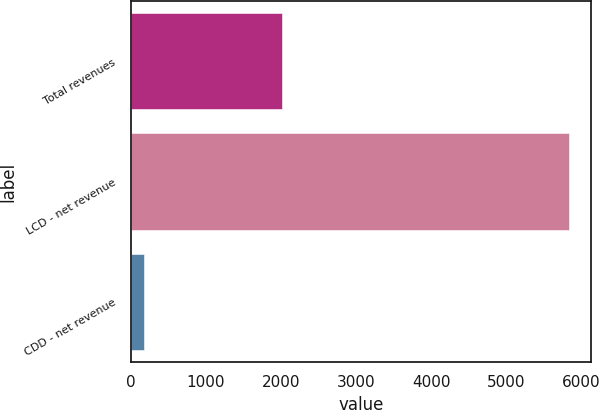Convert chart to OTSL. <chart><loc_0><loc_0><loc_500><loc_500><bar_chart><fcel>Total revenues<fcel>LCD - net revenue<fcel>CDD - net revenue<nl><fcel>2014<fcel>5838<fcel>173.6<nl></chart> 